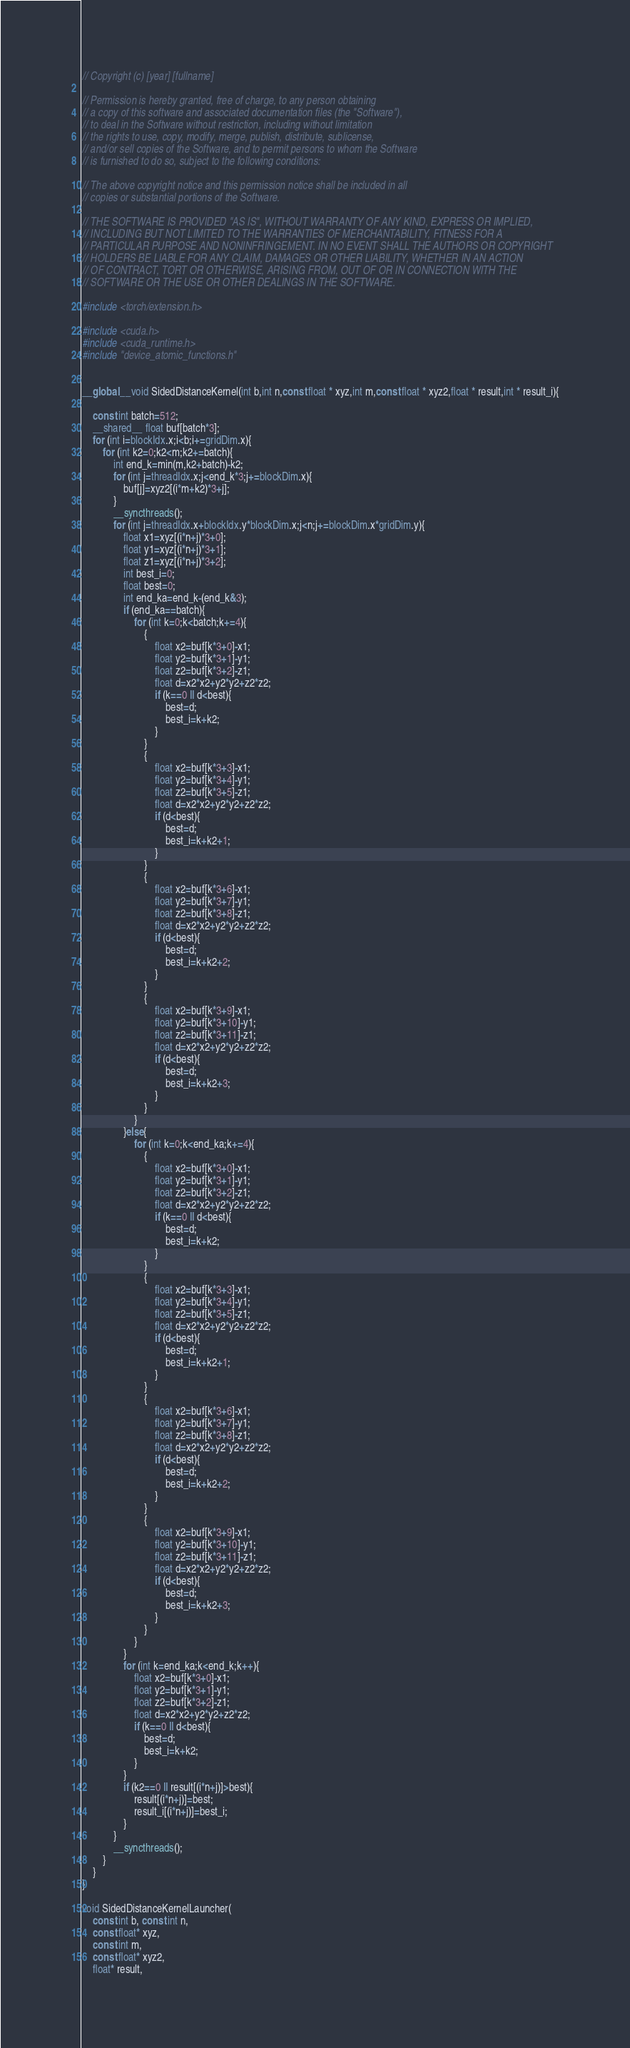Convert code to text. <code><loc_0><loc_0><loc_500><loc_500><_Cuda_>// Copyright (c) [year] [fullname]

// Permission is hereby granted, free of charge, to any person obtaining
// a copy of this software and associated documentation files (the "Software"),
// to deal in the Software without restriction, including without limitation
// the rights to use, copy, modify, merge, publish, distribute, sublicense,
// and/or sell copies of the Software, and to permit persons to whom the Software
// is furnished to do so, subject to the following conditions:

// The above copyright notice and this permission notice shall be included in all
// copies or substantial portions of the Software.

// THE SOFTWARE IS PROVIDED "AS IS", WITHOUT WARRANTY OF ANY KIND, EXPRESS OR IMPLIED,
// INCLUDING BUT NOT LIMITED TO THE WARRANTIES OF MERCHANTABILITY, FITNESS FOR A
// PARTICULAR PURPOSE AND NONINFRINGEMENT. IN NO EVENT SHALL THE AUTHORS OR COPYRIGHT
// HOLDERS BE LIABLE FOR ANY CLAIM, DAMAGES OR OTHER LIABILITY, WHETHER IN AN ACTION
// OF CONTRACT, TORT OR OTHERWISE, ARISING FROM, OUT OF OR IN CONNECTION WITH THE
// SOFTWARE OR THE USE OR OTHER DEALINGS IN THE SOFTWARE.

#include <torch/extension.h>

#include <cuda.h>
#include <cuda_runtime.h>
#include "device_atomic_functions.h"


__global__ void SidedDistanceKernel(int b,int n,const float * xyz,int m,const float * xyz2,float * result,int * result_i){

    const int batch=512;
    __shared__ float buf[batch*3];
    for (int i=blockIdx.x;i<b;i+=gridDim.x){
        for (int k2=0;k2<m;k2+=batch){
            int end_k=min(m,k2+batch)-k2;
            for (int j=threadIdx.x;j<end_k*3;j+=blockDim.x){
                buf[j]=xyz2[(i*m+k2)*3+j];
            }
            __syncthreads();
            for (int j=threadIdx.x+blockIdx.y*blockDim.x;j<n;j+=blockDim.x*gridDim.y){
                float x1=xyz[(i*n+j)*3+0];
                float y1=xyz[(i*n+j)*3+1];
                float z1=xyz[(i*n+j)*3+2];
                int best_i=0;
                float best=0;
                int end_ka=end_k-(end_k&3);
                if (end_ka==batch){
                    for (int k=0;k<batch;k+=4){
                        {
                            float x2=buf[k*3+0]-x1;
                            float y2=buf[k*3+1]-y1;
                            float z2=buf[k*3+2]-z1;
                            float d=x2*x2+y2*y2+z2*z2;
                            if (k==0 || d<best){
                                best=d;
                                best_i=k+k2;
                            }
                        }
                        {
                            float x2=buf[k*3+3]-x1;
                            float y2=buf[k*3+4]-y1;
                            float z2=buf[k*3+5]-z1;
                            float d=x2*x2+y2*y2+z2*z2;
                            if (d<best){
                                best=d;
                                best_i=k+k2+1;
                            }
                        }
                        {
                            float x2=buf[k*3+6]-x1;
                            float y2=buf[k*3+7]-y1;
                            float z2=buf[k*3+8]-z1;
                            float d=x2*x2+y2*y2+z2*z2;
                            if (d<best){
                                best=d;
                                best_i=k+k2+2;
                            }
                        }
                        {
                            float x2=buf[k*3+9]-x1;
                            float y2=buf[k*3+10]-y1;
                            float z2=buf[k*3+11]-z1;
                            float d=x2*x2+y2*y2+z2*z2;
                            if (d<best){
                                best=d;
                                best_i=k+k2+3;
                            }
                        }
                    }
                }else{
                    for (int k=0;k<end_ka;k+=4){
                        {
                            float x2=buf[k*3+0]-x1;
                            float y2=buf[k*3+1]-y1;
                            float z2=buf[k*3+2]-z1;
                            float d=x2*x2+y2*y2+z2*z2;
                            if (k==0 || d<best){
                                best=d;
                                best_i=k+k2;
                            }
                        }
                        {
                            float x2=buf[k*3+3]-x1;
                            float y2=buf[k*3+4]-y1;
                            float z2=buf[k*3+5]-z1;
                            float d=x2*x2+y2*y2+z2*z2;
                            if (d<best){
                                best=d;
                                best_i=k+k2+1;
                            }
                        }
                        {
                            float x2=buf[k*3+6]-x1;
                            float y2=buf[k*3+7]-y1;
                            float z2=buf[k*3+8]-z1;
                            float d=x2*x2+y2*y2+z2*z2;
                            if (d<best){
                                best=d;
                                best_i=k+k2+2;
                            }
                        }
                        {
                            float x2=buf[k*3+9]-x1;
                            float y2=buf[k*3+10]-y1;
                            float z2=buf[k*3+11]-z1;
                            float d=x2*x2+y2*y2+z2*z2;
                            if (d<best){
                                best=d;
                                best_i=k+k2+3;
                            }
                        }
                    }
                }
                for (int k=end_ka;k<end_k;k++){
                    float x2=buf[k*3+0]-x1;
                    float y2=buf[k*3+1]-y1;
                    float z2=buf[k*3+2]-z1;
                    float d=x2*x2+y2*y2+z2*z2;
                    if (k==0 || d<best){
                        best=d;
                        best_i=k+k2;
                    }
                }
                if (k2==0 || result[(i*n+j)]>best){
                    result[(i*n+j)]=best;
                    result_i[(i*n+j)]=best_i;
                }
            }
            __syncthreads();
        }
    }
}

void SidedDistanceKernelLauncher(
    const int b, const int n,
    const float* xyz,
    const int m,
    const float* xyz2,
    float* result,</code> 